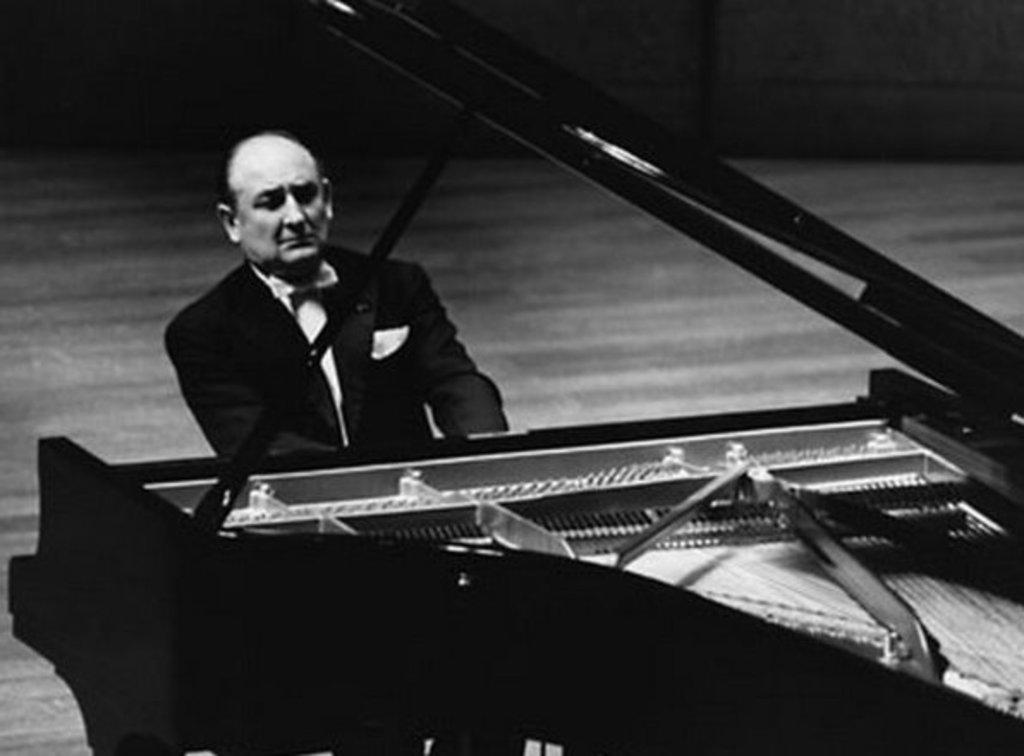Who is present in the image? There is a person in the image. What is the person doing in the image? The person is sitting. What object is in front of the person? The person is in front of a piano. What type of authority does the person have over the line in the image? There is no line present in the image, so the person does not have any authority over a line. 